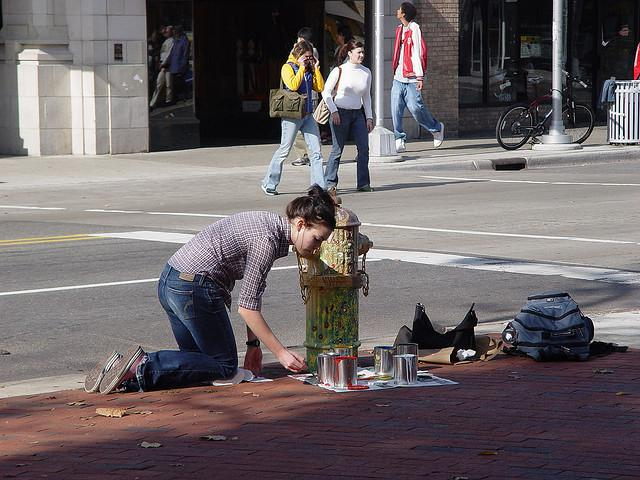What kind of brush is being used?

Choices:
A) paint
B) hair
C) tooth
D) pet paint 